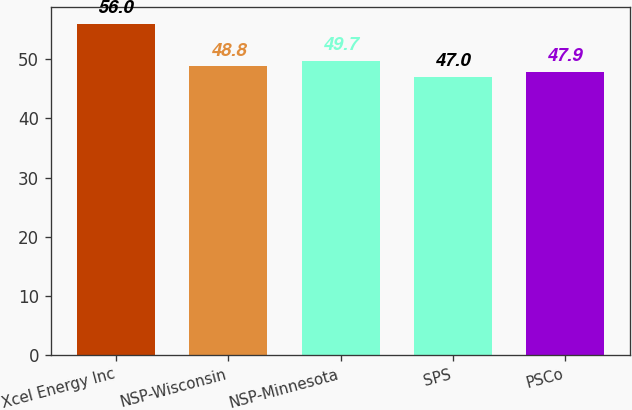Convert chart. <chart><loc_0><loc_0><loc_500><loc_500><bar_chart><fcel>Xcel Energy Inc<fcel>NSP-Wisconsin<fcel>NSP-Minnesota<fcel>SPS<fcel>PSCo<nl><fcel>56<fcel>48.8<fcel>49.7<fcel>47<fcel>47.9<nl></chart> 